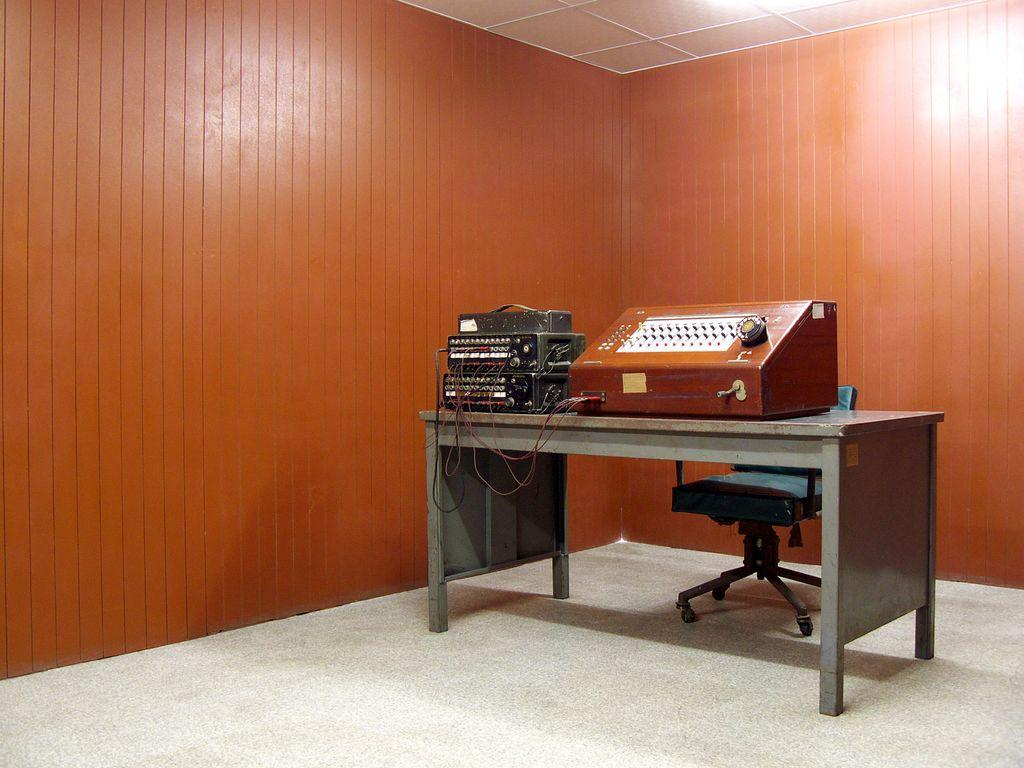What is the main object in the center of the image? There is a table in the center of the image. What is placed on the table? There is an equipment on the table. What can be seen in the background of the image? There is a wall, a ceiling, a chair, and a floor in the background of the image. What type of jam is being used to glue the match to the table in the image? There is no jam, glue, or match present in the image. 